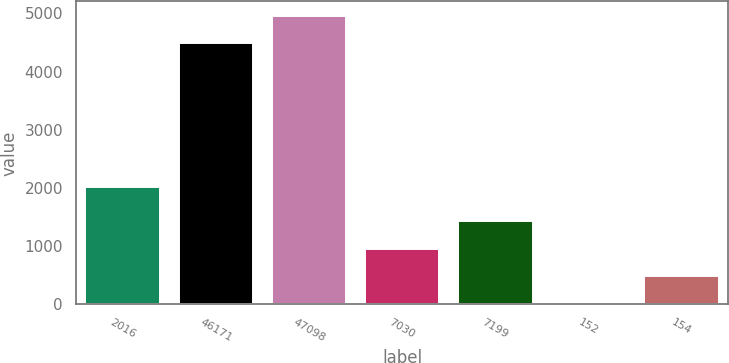Convert chart. <chart><loc_0><loc_0><loc_500><loc_500><bar_chart><fcel>2016<fcel>46171<fcel>47098<fcel>7030<fcel>7199<fcel>152<fcel>154<nl><fcel>2015<fcel>4485.5<fcel>4956.79<fcel>956.58<fcel>1427.87<fcel>14<fcel>485.29<nl></chart> 